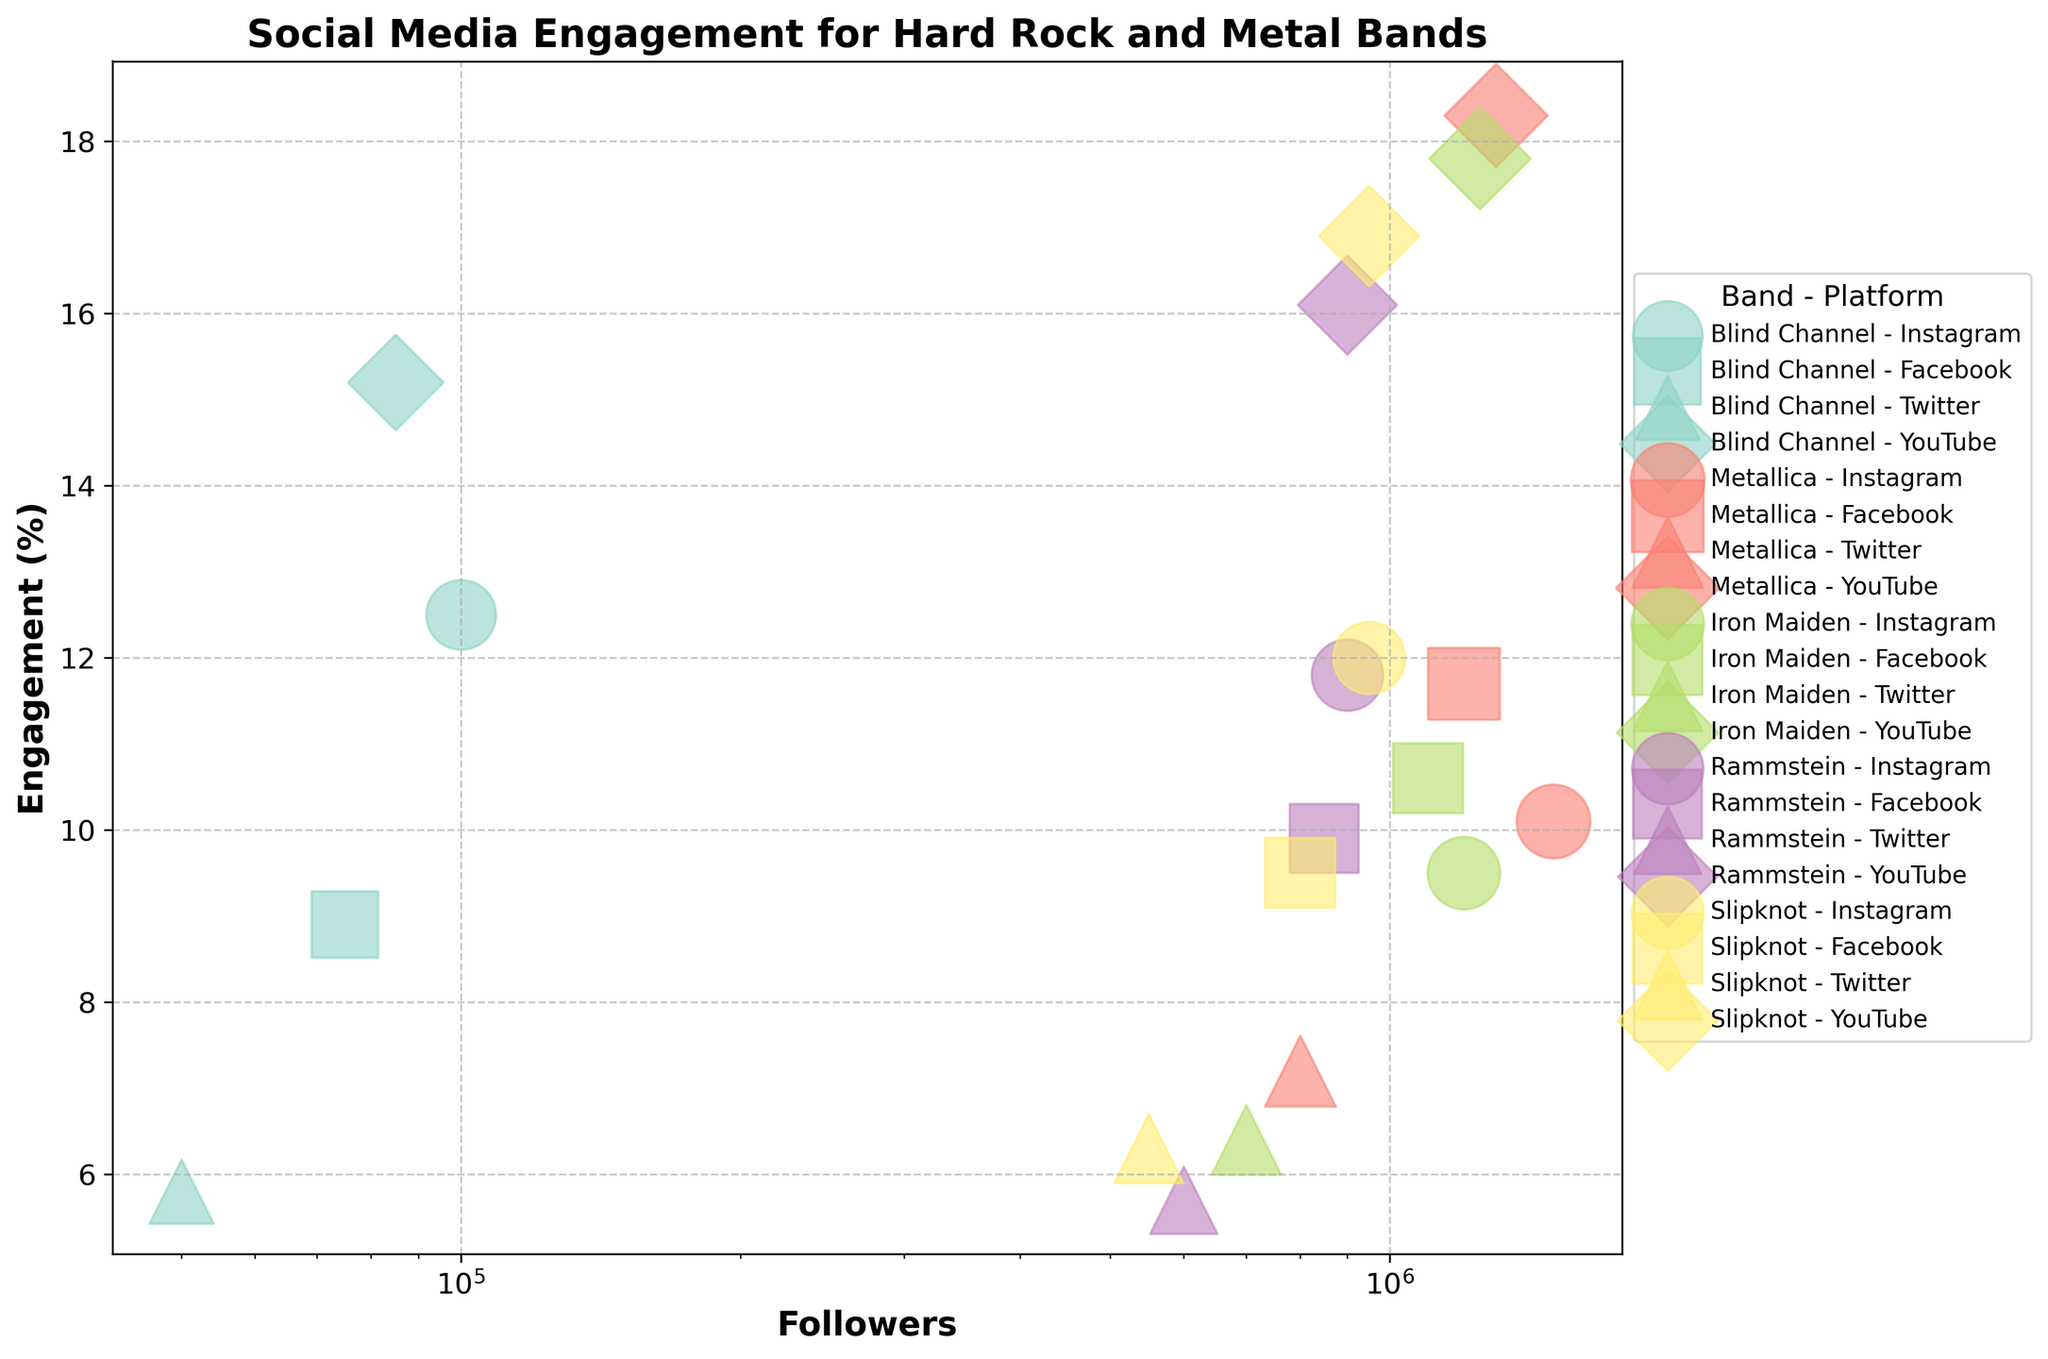What is the title of the figure? The title is usually found at the top of the figure and provides an overview or main theme of the plot. In this case, we look at the top to find it.
Answer: Social Media Engagement for Hard Rock and Metal Bands What does the x-axis represent in this figure? The x-axis typically has a label that describes what it represents. Here, it is labeled "Followers," indicating the number of followers on social media platforms.
Answer: Followers Which band has the highest engagement rate on Instagram? First, identify the Instagram bubbles for each band by their color and marker shape. Then, compare the position of these bubbles on the y-axis to find the highest rate.
Answer: Blind Channel Which band has the most followers on YouTube? To determine this, look for the YouTube bubbles (specific marker) and check which has the furthest right position on the x-axis (log scale).
Answer: Metallica What is the average engagement rate on YouTube across all bands? Find the engagement rates for all YouTube bubbles, sum them up and divide by the number of data points. Engagement rates: 15.2%, 18.3%, 17.8%, 16.1%, 16.9%. (15.2 + 18.3 + 17.8 + 16.1 + 16.9)/5 = 16.86%
Answer: 16.86% Which band has the lowest popularity score? The popularity scores are represented by the size of bubbles. Smaller bubbles indicate lower popularity. Find the smallest bubble and the associated band.
Answer: Blind Channel How does Slipknot’s engagement rate on Facebook compare to that on Instagram? Locate Slipknot’s Facebook and Instagram bubbles (different markers) and compare their y-axis positions.
Answer: Slipknot's engagement on Instagram (12.0%) is higher than on Facebook (9.5%) Which social media platform generally has the highest engagement rates for all bands? Compare engagement rates (y-axis positions) across all platforms and identify which platform has the higher bubbles more consistently.
Answer: YouTube What is the sum of the followers on Instagram for Blind Channel and Iron Maiden? Check the follower count for Blind Channel on Instagram (100,000) and Iron Maiden on Instagram (1,200,000), then add them together. 100,000 + 1,200,000 = 1,300,000
Answer: 1,300,000 Between Metallica and Rammstein, which band has a higher engagement rate on Facebook? Compare the Facebook bubbles for both Metallica and Rammstein, and check their positions on the y-axis.
Answer: Metallica 